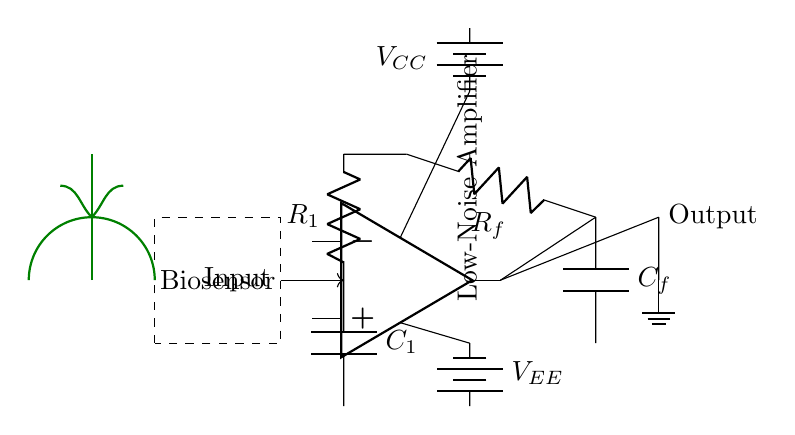What is the main purpose of this circuit? The circuit is designed as a low-noise amplifier, indicated by the label on the diagram. It is meant to enhance weak biosensor signals specifically in plant research.
Answer: low-noise amplifier What components provide feedback in this circuit? The feedback is provided by the feedback resistor R_f and the feedback capacitor C_f, which connect the output of the operational amplifier back to its inverting input.
Answer: R_f, C_f What is the role of capacitors in this amplifier circuit? The capacitors, C_1 and C_f, serve to reduce noise in the circuit. C_1 filters out high-frequency noise at the input, and C_f helps smooth the feedback signal.
Answer: noise reduction What type of power supply is used in this circuit? The circuit uses a dual battery power supply, indicated by the presence of V_CC and V_EE, which provide positive and negative voltage to the operational amplifier.
Answer: dual battery What does the dashed rectangle represent in this circuit? The dashed rectangle indicates the biosensor, which is the input source of weak signals that the amplifier works to enhance.
Answer: biosensor What is the value of R_1 in this circuit? The value of R_1 is not provided directly in the visual information; thus, the schematic does not specify it.
Answer: unspecified What is the relationship between the biosensor and the amplifier? The biosensor acts as the input signal source for the low-noise amplifier, which amplifies the weak signals detected by the biosensor for further analysis.
Answer: input signal source 